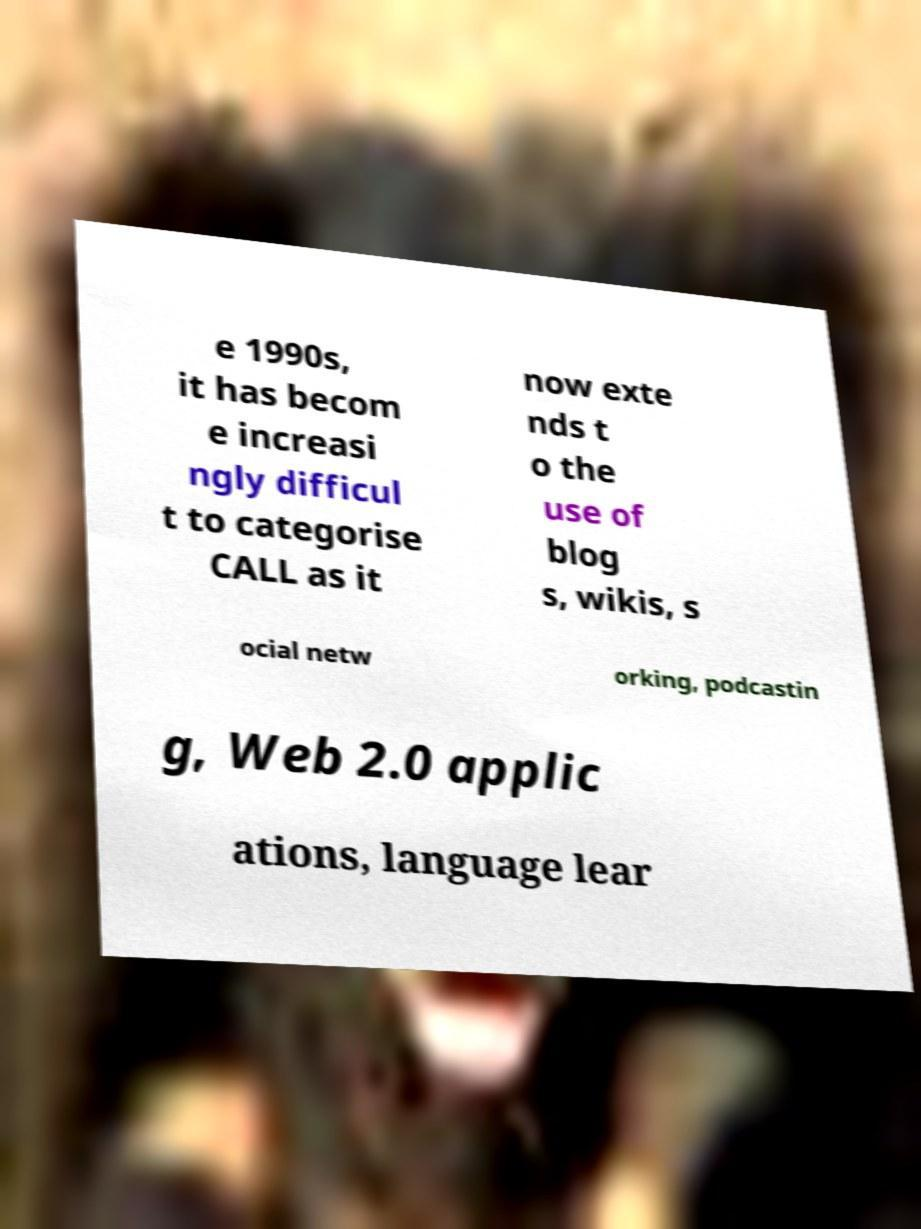How has technology integration into language learning changed since the era alluded to in the image? Since the time referenced in the image, technology integration into language learning has advanced tremendously. Mobile learning via smartphones and tablets, adaptive learning systems powered by AI, and immersive environments using virtual and augmented reality are creating personalized, efficient, and engaging language learning experiences. These sophisticated tools can cater to individual learning styles and help users progress at their own pace. 